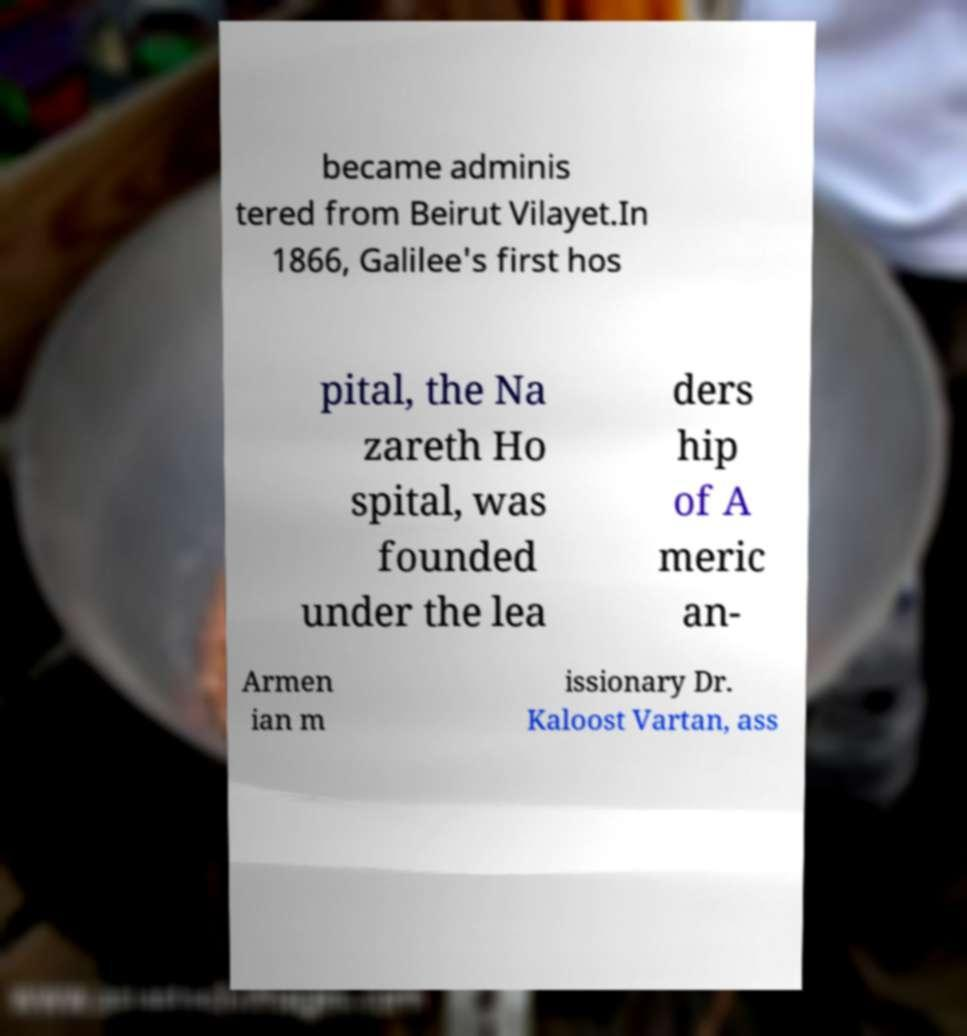Can you accurately transcribe the text from the provided image for me? became adminis tered from Beirut Vilayet.In 1866, Galilee's first hos pital, the Na zareth Ho spital, was founded under the lea ders hip of A meric an- Armen ian m issionary Dr. Kaloost Vartan, ass 